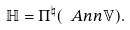<formula> <loc_0><loc_0><loc_500><loc_500>\mathbb { H } = \Pi ^ { \natural } ( \ A n n \mathbb { V } ) .</formula> 